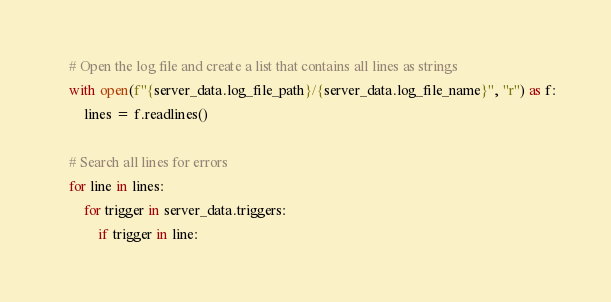<code> <loc_0><loc_0><loc_500><loc_500><_Python_>    # Open the log file and create a list that contains all lines as strings
    with open(f"{server_data.log_file_path}/{server_data.log_file_name}", "r") as f:
        lines = f.readlines()
    
    # Search all lines for errors
    for line in lines:
        for trigger in server_data.triggers:
            if trigger in line:</code> 